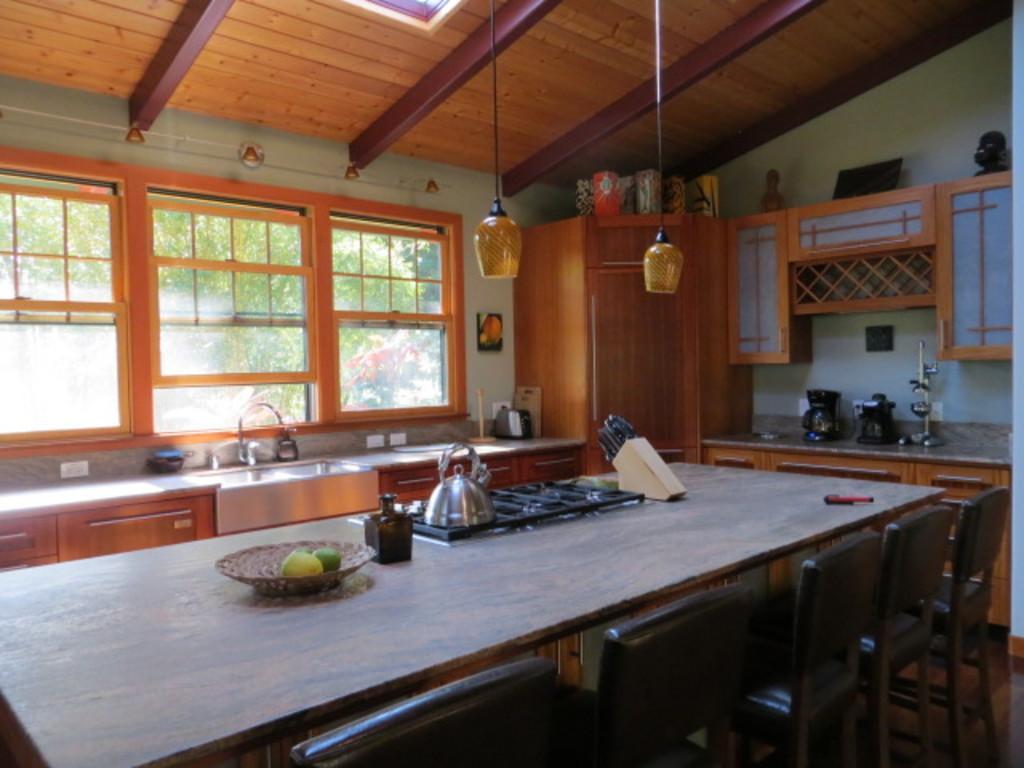Could you give a brief overview of what you see in this image? This is the picture of a room. In this image there are fruits in the basket and there is a kettle on the stove and there are knives and there is a jar on the table. In the foreground there are chairs. At the back there is a sink and there are objects on the table. On the right side of the image there are objects on the table and there are cupboards and there are objects on the top of the cupboards. At top there is a wooden roof and there are lights hanging from the ceiling. On the left side of the image there are trees behind the window. 